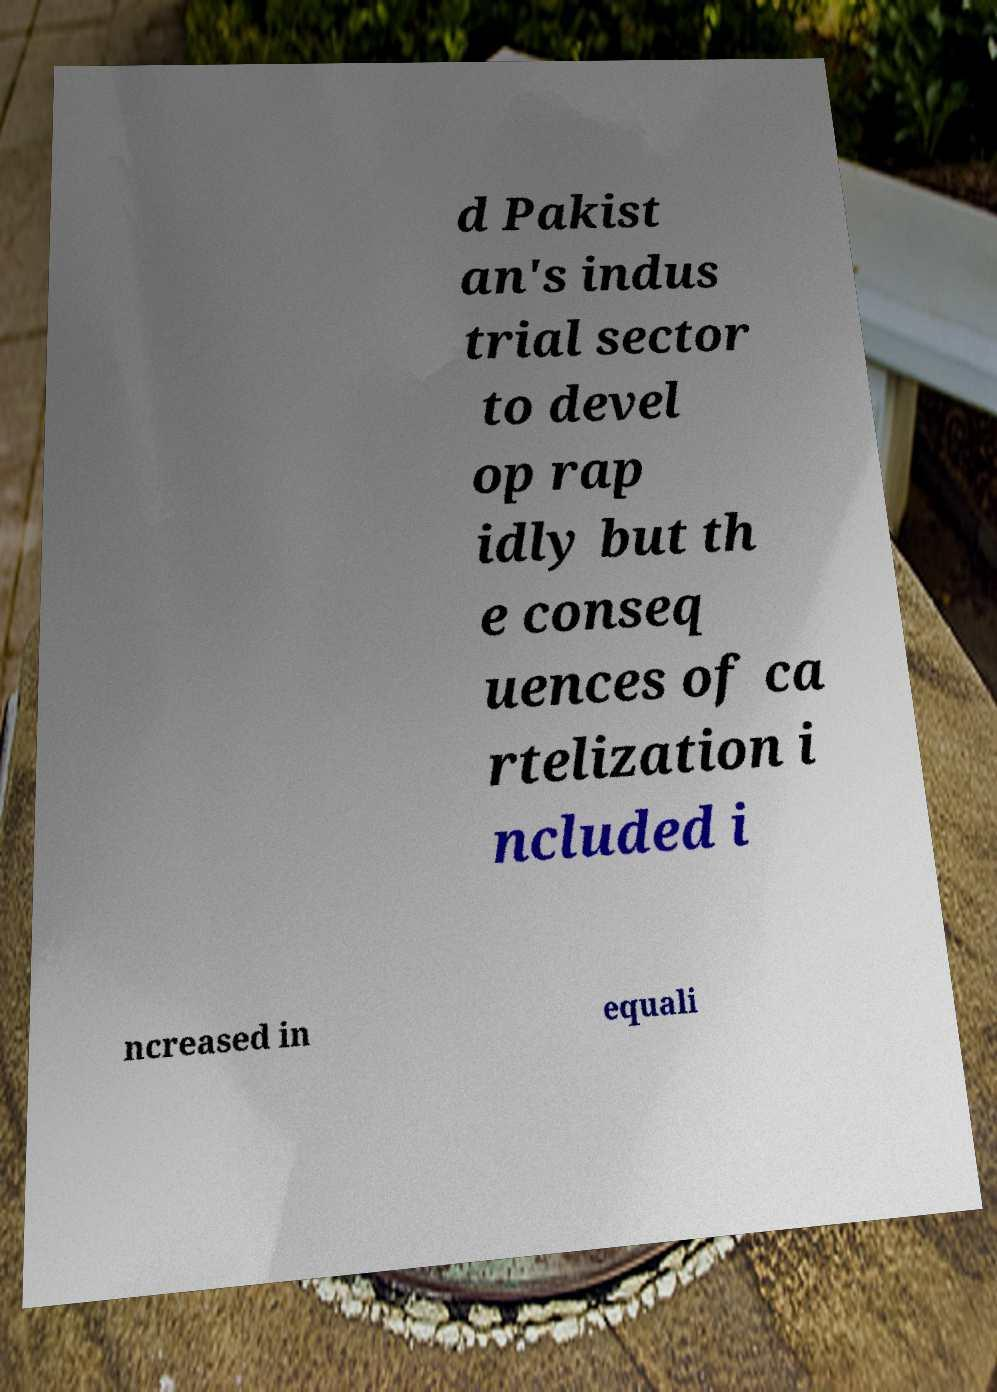Please identify and transcribe the text found in this image. d Pakist an's indus trial sector to devel op rap idly but th e conseq uences of ca rtelization i ncluded i ncreased in equali 